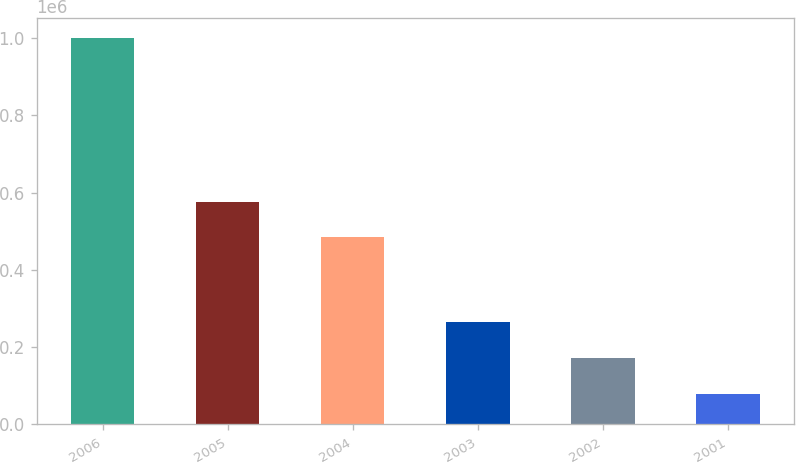<chart> <loc_0><loc_0><loc_500><loc_500><bar_chart><fcel>2006<fcel>2005<fcel>2004<fcel>2003<fcel>2002<fcel>2001<nl><fcel>1.0002e+06<fcel>576090<fcel>484050<fcel>263880<fcel>171840<fcel>79800<nl></chart> 